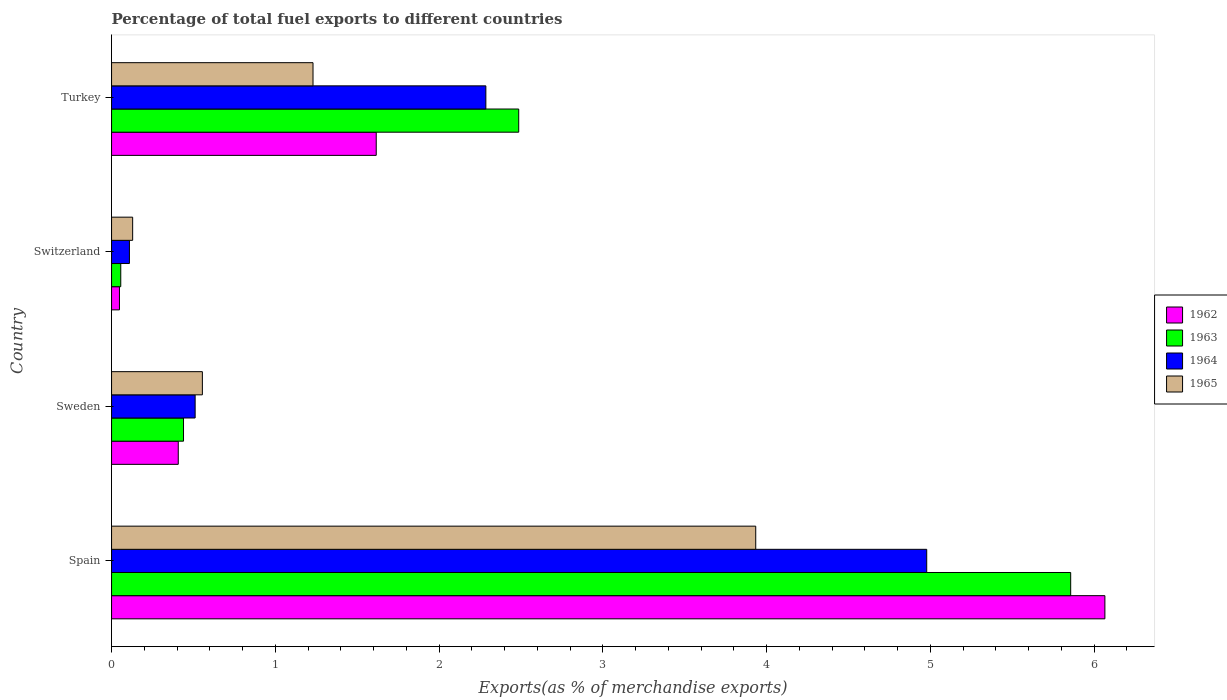How many groups of bars are there?
Make the answer very short. 4. Are the number of bars per tick equal to the number of legend labels?
Your response must be concise. Yes. What is the label of the 2nd group of bars from the top?
Your answer should be very brief. Switzerland. In how many cases, is the number of bars for a given country not equal to the number of legend labels?
Your answer should be very brief. 0. What is the percentage of exports to different countries in 1964 in Spain?
Offer a very short reply. 4.98. Across all countries, what is the maximum percentage of exports to different countries in 1963?
Your response must be concise. 5.86. Across all countries, what is the minimum percentage of exports to different countries in 1963?
Offer a very short reply. 0.06. In which country was the percentage of exports to different countries in 1964 maximum?
Make the answer very short. Spain. In which country was the percentage of exports to different countries in 1963 minimum?
Offer a terse response. Switzerland. What is the total percentage of exports to different countries in 1965 in the graph?
Your answer should be very brief. 5.85. What is the difference between the percentage of exports to different countries in 1962 in Sweden and that in Switzerland?
Your answer should be compact. 0.36. What is the difference between the percentage of exports to different countries in 1964 in Switzerland and the percentage of exports to different countries in 1965 in Spain?
Your response must be concise. -3.82. What is the average percentage of exports to different countries in 1962 per country?
Keep it short and to the point. 2.03. What is the difference between the percentage of exports to different countries in 1962 and percentage of exports to different countries in 1964 in Switzerland?
Your response must be concise. -0.06. What is the ratio of the percentage of exports to different countries in 1963 in Sweden to that in Turkey?
Give a very brief answer. 0.18. Is the difference between the percentage of exports to different countries in 1962 in Sweden and Switzerland greater than the difference between the percentage of exports to different countries in 1964 in Sweden and Switzerland?
Offer a very short reply. No. What is the difference between the highest and the second highest percentage of exports to different countries in 1963?
Provide a succinct answer. 3.37. What is the difference between the highest and the lowest percentage of exports to different countries in 1964?
Provide a succinct answer. 4.87. In how many countries, is the percentage of exports to different countries in 1963 greater than the average percentage of exports to different countries in 1963 taken over all countries?
Make the answer very short. 2. Is the sum of the percentage of exports to different countries in 1962 in Spain and Switzerland greater than the maximum percentage of exports to different countries in 1963 across all countries?
Ensure brevity in your answer.  Yes. Is it the case that in every country, the sum of the percentage of exports to different countries in 1965 and percentage of exports to different countries in 1964 is greater than the sum of percentage of exports to different countries in 1963 and percentage of exports to different countries in 1962?
Ensure brevity in your answer.  No. What does the 2nd bar from the top in Turkey represents?
Provide a short and direct response. 1964. How many bars are there?
Give a very brief answer. 16. Are all the bars in the graph horizontal?
Ensure brevity in your answer.  Yes. How many countries are there in the graph?
Give a very brief answer. 4. Are the values on the major ticks of X-axis written in scientific E-notation?
Your response must be concise. No. Does the graph contain any zero values?
Your answer should be compact. No. Where does the legend appear in the graph?
Your answer should be compact. Center right. How are the legend labels stacked?
Ensure brevity in your answer.  Vertical. What is the title of the graph?
Your response must be concise. Percentage of total fuel exports to different countries. What is the label or title of the X-axis?
Give a very brief answer. Exports(as % of merchandise exports). What is the Exports(as % of merchandise exports) in 1962 in Spain?
Your answer should be very brief. 6.07. What is the Exports(as % of merchandise exports) of 1963 in Spain?
Offer a terse response. 5.86. What is the Exports(as % of merchandise exports) of 1964 in Spain?
Your response must be concise. 4.98. What is the Exports(as % of merchandise exports) of 1965 in Spain?
Ensure brevity in your answer.  3.93. What is the Exports(as % of merchandise exports) in 1962 in Sweden?
Make the answer very short. 0.41. What is the Exports(as % of merchandise exports) in 1963 in Sweden?
Provide a short and direct response. 0.44. What is the Exports(as % of merchandise exports) of 1964 in Sweden?
Offer a very short reply. 0.51. What is the Exports(as % of merchandise exports) in 1965 in Sweden?
Give a very brief answer. 0.55. What is the Exports(as % of merchandise exports) of 1962 in Switzerland?
Offer a terse response. 0.05. What is the Exports(as % of merchandise exports) of 1963 in Switzerland?
Your answer should be very brief. 0.06. What is the Exports(as % of merchandise exports) of 1964 in Switzerland?
Offer a terse response. 0.11. What is the Exports(as % of merchandise exports) in 1965 in Switzerland?
Provide a short and direct response. 0.13. What is the Exports(as % of merchandise exports) in 1962 in Turkey?
Provide a short and direct response. 1.62. What is the Exports(as % of merchandise exports) of 1963 in Turkey?
Your answer should be very brief. 2.49. What is the Exports(as % of merchandise exports) of 1964 in Turkey?
Provide a succinct answer. 2.29. What is the Exports(as % of merchandise exports) in 1965 in Turkey?
Provide a succinct answer. 1.23. Across all countries, what is the maximum Exports(as % of merchandise exports) of 1962?
Your response must be concise. 6.07. Across all countries, what is the maximum Exports(as % of merchandise exports) of 1963?
Your answer should be compact. 5.86. Across all countries, what is the maximum Exports(as % of merchandise exports) in 1964?
Ensure brevity in your answer.  4.98. Across all countries, what is the maximum Exports(as % of merchandise exports) in 1965?
Offer a very short reply. 3.93. Across all countries, what is the minimum Exports(as % of merchandise exports) in 1962?
Your answer should be very brief. 0.05. Across all countries, what is the minimum Exports(as % of merchandise exports) in 1963?
Offer a very short reply. 0.06. Across all countries, what is the minimum Exports(as % of merchandise exports) of 1964?
Provide a short and direct response. 0.11. Across all countries, what is the minimum Exports(as % of merchandise exports) in 1965?
Your answer should be compact. 0.13. What is the total Exports(as % of merchandise exports) in 1962 in the graph?
Your response must be concise. 8.14. What is the total Exports(as % of merchandise exports) of 1963 in the graph?
Provide a short and direct response. 8.84. What is the total Exports(as % of merchandise exports) of 1964 in the graph?
Provide a succinct answer. 7.88. What is the total Exports(as % of merchandise exports) in 1965 in the graph?
Your answer should be compact. 5.85. What is the difference between the Exports(as % of merchandise exports) in 1962 in Spain and that in Sweden?
Offer a very short reply. 5.66. What is the difference between the Exports(as % of merchandise exports) in 1963 in Spain and that in Sweden?
Offer a very short reply. 5.42. What is the difference between the Exports(as % of merchandise exports) of 1964 in Spain and that in Sweden?
Your response must be concise. 4.47. What is the difference between the Exports(as % of merchandise exports) in 1965 in Spain and that in Sweden?
Offer a very short reply. 3.38. What is the difference between the Exports(as % of merchandise exports) of 1962 in Spain and that in Switzerland?
Provide a short and direct response. 6.02. What is the difference between the Exports(as % of merchandise exports) in 1963 in Spain and that in Switzerland?
Provide a succinct answer. 5.8. What is the difference between the Exports(as % of merchandise exports) of 1964 in Spain and that in Switzerland?
Your answer should be very brief. 4.87. What is the difference between the Exports(as % of merchandise exports) of 1965 in Spain and that in Switzerland?
Make the answer very short. 3.81. What is the difference between the Exports(as % of merchandise exports) of 1962 in Spain and that in Turkey?
Offer a very short reply. 4.45. What is the difference between the Exports(as % of merchandise exports) in 1963 in Spain and that in Turkey?
Your response must be concise. 3.37. What is the difference between the Exports(as % of merchandise exports) of 1964 in Spain and that in Turkey?
Make the answer very short. 2.69. What is the difference between the Exports(as % of merchandise exports) in 1965 in Spain and that in Turkey?
Provide a succinct answer. 2.7. What is the difference between the Exports(as % of merchandise exports) in 1962 in Sweden and that in Switzerland?
Provide a succinct answer. 0.36. What is the difference between the Exports(as % of merchandise exports) in 1963 in Sweden and that in Switzerland?
Your response must be concise. 0.38. What is the difference between the Exports(as % of merchandise exports) of 1964 in Sweden and that in Switzerland?
Provide a succinct answer. 0.4. What is the difference between the Exports(as % of merchandise exports) of 1965 in Sweden and that in Switzerland?
Keep it short and to the point. 0.43. What is the difference between the Exports(as % of merchandise exports) of 1962 in Sweden and that in Turkey?
Your answer should be compact. -1.21. What is the difference between the Exports(as % of merchandise exports) in 1963 in Sweden and that in Turkey?
Provide a short and direct response. -2.05. What is the difference between the Exports(as % of merchandise exports) of 1964 in Sweden and that in Turkey?
Give a very brief answer. -1.78. What is the difference between the Exports(as % of merchandise exports) in 1965 in Sweden and that in Turkey?
Provide a short and direct response. -0.68. What is the difference between the Exports(as % of merchandise exports) of 1962 in Switzerland and that in Turkey?
Provide a succinct answer. -1.57. What is the difference between the Exports(as % of merchandise exports) in 1963 in Switzerland and that in Turkey?
Your response must be concise. -2.43. What is the difference between the Exports(as % of merchandise exports) of 1964 in Switzerland and that in Turkey?
Your answer should be compact. -2.18. What is the difference between the Exports(as % of merchandise exports) in 1965 in Switzerland and that in Turkey?
Make the answer very short. -1.1. What is the difference between the Exports(as % of merchandise exports) of 1962 in Spain and the Exports(as % of merchandise exports) of 1963 in Sweden?
Provide a short and direct response. 5.63. What is the difference between the Exports(as % of merchandise exports) of 1962 in Spain and the Exports(as % of merchandise exports) of 1964 in Sweden?
Your response must be concise. 5.56. What is the difference between the Exports(as % of merchandise exports) of 1962 in Spain and the Exports(as % of merchandise exports) of 1965 in Sweden?
Offer a very short reply. 5.51. What is the difference between the Exports(as % of merchandise exports) in 1963 in Spain and the Exports(as % of merchandise exports) in 1964 in Sweden?
Make the answer very short. 5.35. What is the difference between the Exports(as % of merchandise exports) in 1963 in Spain and the Exports(as % of merchandise exports) in 1965 in Sweden?
Offer a very short reply. 5.3. What is the difference between the Exports(as % of merchandise exports) of 1964 in Spain and the Exports(as % of merchandise exports) of 1965 in Sweden?
Give a very brief answer. 4.42. What is the difference between the Exports(as % of merchandise exports) in 1962 in Spain and the Exports(as % of merchandise exports) in 1963 in Switzerland?
Keep it short and to the point. 6.01. What is the difference between the Exports(as % of merchandise exports) in 1962 in Spain and the Exports(as % of merchandise exports) in 1964 in Switzerland?
Make the answer very short. 5.96. What is the difference between the Exports(as % of merchandise exports) in 1962 in Spain and the Exports(as % of merchandise exports) in 1965 in Switzerland?
Your response must be concise. 5.94. What is the difference between the Exports(as % of merchandise exports) in 1963 in Spain and the Exports(as % of merchandise exports) in 1964 in Switzerland?
Your answer should be compact. 5.75. What is the difference between the Exports(as % of merchandise exports) of 1963 in Spain and the Exports(as % of merchandise exports) of 1965 in Switzerland?
Offer a very short reply. 5.73. What is the difference between the Exports(as % of merchandise exports) in 1964 in Spain and the Exports(as % of merchandise exports) in 1965 in Switzerland?
Your response must be concise. 4.85. What is the difference between the Exports(as % of merchandise exports) in 1962 in Spain and the Exports(as % of merchandise exports) in 1963 in Turkey?
Make the answer very short. 3.58. What is the difference between the Exports(as % of merchandise exports) in 1962 in Spain and the Exports(as % of merchandise exports) in 1964 in Turkey?
Give a very brief answer. 3.78. What is the difference between the Exports(as % of merchandise exports) of 1962 in Spain and the Exports(as % of merchandise exports) of 1965 in Turkey?
Give a very brief answer. 4.84. What is the difference between the Exports(as % of merchandise exports) of 1963 in Spain and the Exports(as % of merchandise exports) of 1964 in Turkey?
Make the answer very short. 3.57. What is the difference between the Exports(as % of merchandise exports) in 1963 in Spain and the Exports(as % of merchandise exports) in 1965 in Turkey?
Offer a terse response. 4.63. What is the difference between the Exports(as % of merchandise exports) in 1964 in Spain and the Exports(as % of merchandise exports) in 1965 in Turkey?
Ensure brevity in your answer.  3.75. What is the difference between the Exports(as % of merchandise exports) of 1962 in Sweden and the Exports(as % of merchandise exports) of 1963 in Switzerland?
Keep it short and to the point. 0.35. What is the difference between the Exports(as % of merchandise exports) in 1962 in Sweden and the Exports(as % of merchandise exports) in 1964 in Switzerland?
Provide a short and direct response. 0.3. What is the difference between the Exports(as % of merchandise exports) in 1962 in Sweden and the Exports(as % of merchandise exports) in 1965 in Switzerland?
Your answer should be very brief. 0.28. What is the difference between the Exports(as % of merchandise exports) of 1963 in Sweden and the Exports(as % of merchandise exports) of 1964 in Switzerland?
Provide a succinct answer. 0.33. What is the difference between the Exports(as % of merchandise exports) of 1963 in Sweden and the Exports(as % of merchandise exports) of 1965 in Switzerland?
Provide a short and direct response. 0.31. What is the difference between the Exports(as % of merchandise exports) of 1964 in Sweden and the Exports(as % of merchandise exports) of 1965 in Switzerland?
Offer a terse response. 0.38. What is the difference between the Exports(as % of merchandise exports) of 1962 in Sweden and the Exports(as % of merchandise exports) of 1963 in Turkey?
Your answer should be compact. -2.08. What is the difference between the Exports(as % of merchandise exports) of 1962 in Sweden and the Exports(as % of merchandise exports) of 1964 in Turkey?
Your answer should be compact. -1.88. What is the difference between the Exports(as % of merchandise exports) in 1962 in Sweden and the Exports(as % of merchandise exports) in 1965 in Turkey?
Your answer should be compact. -0.82. What is the difference between the Exports(as % of merchandise exports) of 1963 in Sweden and the Exports(as % of merchandise exports) of 1964 in Turkey?
Provide a succinct answer. -1.85. What is the difference between the Exports(as % of merchandise exports) in 1963 in Sweden and the Exports(as % of merchandise exports) in 1965 in Turkey?
Provide a short and direct response. -0.79. What is the difference between the Exports(as % of merchandise exports) in 1964 in Sweden and the Exports(as % of merchandise exports) in 1965 in Turkey?
Your response must be concise. -0.72. What is the difference between the Exports(as % of merchandise exports) of 1962 in Switzerland and the Exports(as % of merchandise exports) of 1963 in Turkey?
Offer a very short reply. -2.44. What is the difference between the Exports(as % of merchandise exports) in 1962 in Switzerland and the Exports(as % of merchandise exports) in 1964 in Turkey?
Make the answer very short. -2.24. What is the difference between the Exports(as % of merchandise exports) of 1962 in Switzerland and the Exports(as % of merchandise exports) of 1965 in Turkey?
Provide a succinct answer. -1.18. What is the difference between the Exports(as % of merchandise exports) in 1963 in Switzerland and the Exports(as % of merchandise exports) in 1964 in Turkey?
Your answer should be compact. -2.23. What is the difference between the Exports(as % of merchandise exports) of 1963 in Switzerland and the Exports(as % of merchandise exports) of 1965 in Turkey?
Provide a succinct answer. -1.17. What is the difference between the Exports(as % of merchandise exports) of 1964 in Switzerland and the Exports(as % of merchandise exports) of 1965 in Turkey?
Your response must be concise. -1.12. What is the average Exports(as % of merchandise exports) in 1962 per country?
Ensure brevity in your answer.  2.03. What is the average Exports(as % of merchandise exports) of 1963 per country?
Ensure brevity in your answer.  2.21. What is the average Exports(as % of merchandise exports) in 1964 per country?
Offer a very short reply. 1.97. What is the average Exports(as % of merchandise exports) in 1965 per country?
Your answer should be compact. 1.46. What is the difference between the Exports(as % of merchandise exports) in 1962 and Exports(as % of merchandise exports) in 1963 in Spain?
Keep it short and to the point. 0.21. What is the difference between the Exports(as % of merchandise exports) in 1962 and Exports(as % of merchandise exports) in 1964 in Spain?
Provide a succinct answer. 1.09. What is the difference between the Exports(as % of merchandise exports) of 1962 and Exports(as % of merchandise exports) of 1965 in Spain?
Make the answer very short. 2.13. What is the difference between the Exports(as % of merchandise exports) in 1963 and Exports(as % of merchandise exports) in 1964 in Spain?
Provide a succinct answer. 0.88. What is the difference between the Exports(as % of merchandise exports) of 1963 and Exports(as % of merchandise exports) of 1965 in Spain?
Ensure brevity in your answer.  1.92. What is the difference between the Exports(as % of merchandise exports) in 1964 and Exports(as % of merchandise exports) in 1965 in Spain?
Provide a succinct answer. 1.04. What is the difference between the Exports(as % of merchandise exports) in 1962 and Exports(as % of merchandise exports) in 1963 in Sweden?
Offer a very short reply. -0.03. What is the difference between the Exports(as % of merchandise exports) of 1962 and Exports(as % of merchandise exports) of 1964 in Sweden?
Provide a succinct answer. -0.1. What is the difference between the Exports(as % of merchandise exports) of 1962 and Exports(as % of merchandise exports) of 1965 in Sweden?
Provide a succinct answer. -0.15. What is the difference between the Exports(as % of merchandise exports) in 1963 and Exports(as % of merchandise exports) in 1964 in Sweden?
Make the answer very short. -0.07. What is the difference between the Exports(as % of merchandise exports) in 1963 and Exports(as % of merchandise exports) in 1965 in Sweden?
Your response must be concise. -0.12. What is the difference between the Exports(as % of merchandise exports) in 1964 and Exports(as % of merchandise exports) in 1965 in Sweden?
Your answer should be compact. -0.04. What is the difference between the Exports(as % of merchandise exports) in 1962 and Exports(as % of merchandise exports) in 1963 in Switzerland?
Offer a very short reply. -0.01. What is the difference between the Exports(as % of merchandise exports) of 1962 and Exports(as % of merchandise exports) of 1964 in Switzerland?
Make the answer very short. -0.06. What is the difference between the Exports(as % of merchandise exports) of 1962 and Exports(as % of merchandise exports) of 1965 in Switzerland?
Ensure brevity in your answer.  -0.08. What is the difference between the Exports(as % of merchandise exports) of 1963 and Exports(as % of merchandise exports) of 1964 in Switzerland?
Keep it short and to the point. -0.05. What is the difference between the Exports(as % of merchandise exports) of 1963 and Exports(as % of merchandise exports) of 1965 in Switzerland?
Make the answer very short. -0.07. What is the difference between the Exports(as % of merchandise exports) in 1964 and Exports(as % of merchandise exports) in 1965 in Switzerland?
Provide a succinct answer. -0.02. What is the difference between the Exports(as % of merchandise exports) of 1962 and Exports(as % of merchandise exports) of 1963 in Turkey?
Make the answer very short. -0.87. What is the difference between the Exports(as % of merchandise exports) of 1962 and Exports(as % of merchandise exports) of 1964 in Turkey?
Your answer should be compact. -0.67. What is the difference between the Exports(as % of merchandise exports) in 1962 and Exports(as % of merchandise exports) in 1965 in Turkey?
Offer a terse response. 0.39. What is the difference between the Exports(as % of merchandise exports) in 1963 and Exports(as % of merchandise exports) in 1964 in Turkey?
Offer a very short reply. 0.2. What is the difference between the Exports(as % of merchandise exports) of 1963 and Exports(as % of merchandise exports) of 1965 in Turkey?
Make the answer very short. 1.26. What is the difference between the Exports(as % of merchandise exports) of 1964 and Exports(as % of merchandise exports) of 1965 in Turkey?
Keep it short and to the point. 1.06. What is the ratio of the Exports(as % of merchandise exports) of 1962 in Spain to that in Sweden?
Your response must be concise. 14.89. What is the ratio of the Exports(as % of merchandise exports) of 1963 in Spain to that in Sweden?
Give a very brief answer. 13.33. What is the ratio of the Exports(as % of merchandise exports) of 1964 in Spain to that in Sweden?
Provide a short and direct response. 9.75. What is the ratio of the Exports(as % of merchandise exports) in 1965 in Spain to that in Sweden?
Your response must be concise. 7.09. What is the ratio of the Exports(as % of merchandise exports) in 1962 in Spain to that in Switzerland?
Your answer should be very brief. 125.74. What is the ratio of the Exports(as % of merchandise exports) in 1963 in Spain to that in Switzerland?
Your answer should be compact. 104.12. What is the ratio of the Exports(as % of merchandise exports) of 1964 in Spain to that in Switzerland?
Ensure brevity in your answer.  45.62. What is the ratio of the Exports(as % of merchandise exports) in 1965 in Spain to that in Switzerland?
Give a very brief answer. 30.54. What is the ratio of the Exports(as % of merchandise exports) of 1962 in Spain to that in Turkey?
Offer a terse response. 3.75. What is the ratio of the Exports(as % of merchandise exports) in 1963 in Spain to that in Turkey?
Provide a short and direct response. 2.36. What is the ratio of the Exports(as % of merchandise exports) of 1964 in Spain to that in Turkey?
Your answer should be compact. 2.18. What is the ratio of the Exports(as % of merchandise exports) of 1965 in Spain to that in Turkey?
Offer a very short reply. 3.2. What is the ratio of the Exports(as % of merchandise exports) of 1962 in Sweden to that in Switzerland?
Offer a very short reply. 8.44. What is the ratio of the Exports(as % of merchandise exports) in 1963 in Sweden to that in Switzerland?
Your answer should be compact. 7.81. What is the ratio of the Exports(as % of merchandise exports) in 1964 in Sweden to that in Switzerland?
Your response must be concise. 4.68. What is the ratio of the Exports(as % of merchandise exports) in 1965 in Sweden to that in Switzerland?
Provide a short and direct response. 4.31. What is the ratio of the Exports(as % of merchandise exports) of 1962 in Sweden to that in Turkey?
Provide a short and direct response. 0.25. What is the ratio of the Exports(as % of merchandise exports) in 1963 in Sweden to that in Turkey?
Make the answer very short. 0.18. What is the ratio of the Exports(as % of merchandise exports) of 1964 in Sweden to that in Turkey?
Keep it short and to the point. 0.22. What is the ratio of the Exports(as % of merchandise exports) in 1965 in Sweden to that in Turkey?
Give a very brief answer. 0.45. What is the ratio of the Exports(as % of merchandise exports) of 1962 in Switzerland to that in Turkey?
Keep it short and to the point. 0.03. What is the ratio of the Exports(as % of merchandise exports) of 1963 in Switzerland to that in Turkey?
Make the answer very short. 0.02. What is the ratio of the Exports(as % of merchandise exports) in 1964 in Switzerland to that in Turkey?
Provide a succinct answer. 0.05. What is the ratio of the Exports(as % of merchandise exports) in 1965 in Switzerland to that in Turkey?
Your answer should be compact. 0.1. What is the difference between the highest and the second highest Exports(as % of merchandise exports) in 1962?
Give a very brief answer. 4.45. What is the difference between the highest and the second highest Exports(as % of merchandise exports) of 1963?
Your answer should be compact. 3.37. What is the difference between the highest and the second highest Exports(as % of merchandise exports) in 1964?
Your answer should be compact. 2.69. What is the difference between the highest and the second highest Exports(as % of merchandise exports) of 1965?
Keep it short and to the point. 2.7. What is the difference between the highest and the lowest Exports(as % of merchandise exports) in 1962?
Give a very brief answer. 6.02. What is the difference between the highest and the lowest Exports(as % of merchandise exports) in 1963?
Your response must be concise. 5.8. What is the difference between the highest and the lowest Exports(as % of merchandise exports) in 1964?
Give a very brief answer. 4.87. What is the difference between the highest and the lowest Exports(as % of merchandise exports) of 1965?
Offer a very short reply. 3.81. 